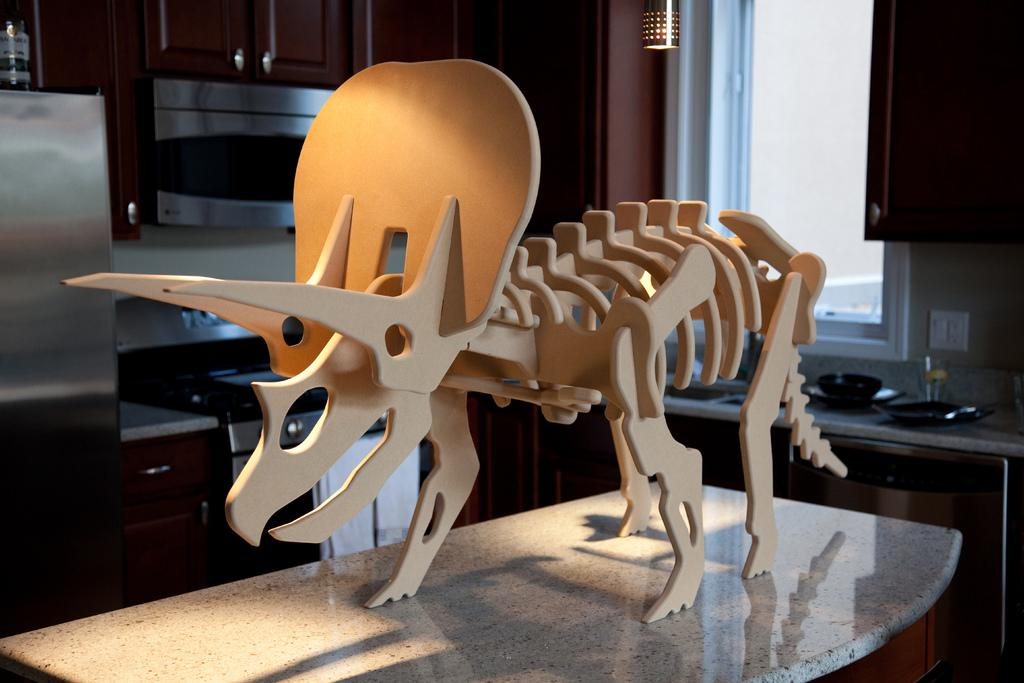What is the main subject of the image? There is a skeleton in the image. What is the skeleton standing on in the image? There is a platform in the image. What type of storage furniture can be seen in the image? There are cupboards in the image. What is a feature of the room that allows natural light to enter? There is a window in the image. What provides illumination in the image? There is a light in the image. What else is present in the image besides the skeleton and platform? There are objects in the image. What type of pest can be seen crawling on the skeleton in the image? There are no pests visible in the image; it only features a skeleton, platform, cupboards, window, light, and other objects. Is there a playground visible in the image? No, there is no playground present in the image. 